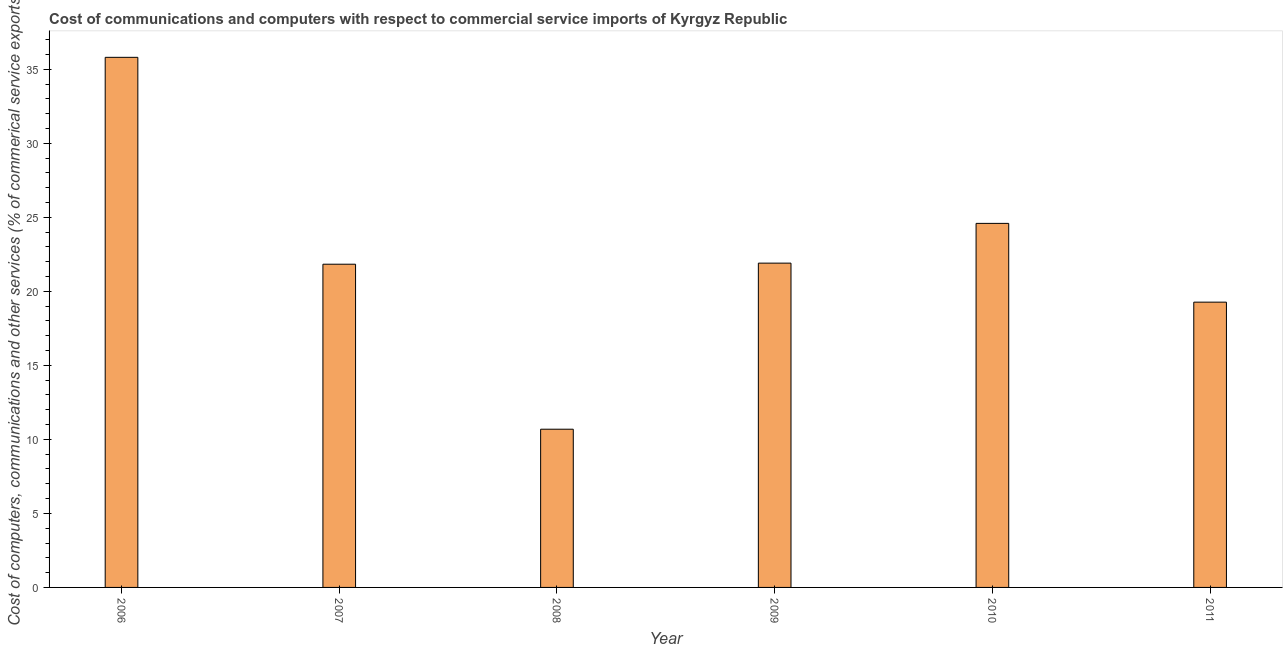Does the graph contain any zero values?
Provide a succinct answer. No. Does the graph contain grids?
Your answer should be compact. No. What is the title of the graph?
Your answer should be very brief. Cost of communications and computers with respect to commercial service imports of Kyrgyz Republic. What is the label or title of the X-axis?
Offer a terse response. Year. What is the label or title of the Y-axis?
Your response must be concise. Cost of computers, communications and other services (% of commerical service exports). What is the  computer and other services in 2008?
Offer a very short reply. 10.69. Across all years, what is the maximum  computer and other services?
Give a very brief answer. 35.81. Across all years, what is the minimum  computer and other services?
Keep it short and to the point. 10.69. What is the sum of the cost of communications?
Offer a terse response. 134.1. What is the difference between the  computer and other services in 2006 and 2010?
Make the answer very short. 11.22. What is the average cost of communications per year?
Provide a succinct answer. 22.35. What is the median cost of communications?
Ensure brevity in your answer.  21.87. What is the ratio of the cost of communications in 2008 to that in 2011?
Offer a terse response. 0.56. Is the difference between the  computer and other services in 2007 and 2011 greater than the difference between any two years?
Ensure brevity in your answer.  No. What is the difference between the highest and the second highest  computer and other services?
Offer a very short reply. 11.22. What is the difference between the highest and the lowest  computer and other services?
Your answer should be very brief. 25.12. In how many years, is the cost of communications greater than the average cost of communications taken over all years?
Provide a succinct answer. 2. How many bars are there?
Your response must be concise. 6. Are all the bars in the graph horizontal?
Make the answer very short. No. How many years are there in the graph?
Offer a terse response. 6. Are the values on the major ticks of Y-axis written in scientific E-notation?
Give a very brief answer. No. What is the Cost of computers, communications and other services (% of commerical service exports) in 2006?
Your response must be concise. 35.81. What is the Cost of computers, communications and other services (% of commerical service exports) in 2007?
Offer a terse response. 21.83. What is the Cost of computers, communications and other services (% of commerical service exports) of 2008?
Give a very brief answer. 10.69. What is the Cost of computers, communications and other services (% of commerical service exports) of 2009?
Provide a short and direct response. 21.91. What is the Cost of computers, communications and other services (% of commerical service exports) in 2010?
Offer a very short reply. 24.59. What is the Cost of computers, communications and other services (% of commerical service exports) of 2011?
Give a very brief answer. 19.27. What is the difference between the Cost of computers, communications and other services (% of commerical service exports) in 2006 and 2007?
Offer a very short reply. 13.98. What is the difference between the Cost of computers, communications and other services (% of commerical service exports) in 2006 and 2008?
Your answer should be very brief. 25.12. What is the difference between the Cost of computers, communications and other services (% of commerical service exports) in 2006 and 2009?
Your answer should be compact. 13.9. What is the difference between the Cost of computers, communications and other services (% of commerical service exports) in 2006 and 2010?
Provide a short and direct response. 11.22. What is the difference between the Cost of computers, communications and other services (% of commerical service exports) in 2006 and 2011?
Offer a very short reply. 16.54. What is the difference between the Cost of computers, communications and other services (% of commerical service exports) in 2007 and 2008?
Keep it short and to the point. 11.15. What is the difference between the Cost of computers, communications and other services (% of commerical service exports) in 2007 and 2009?
Provide a short and direct response. -0.07. What is the difference between the Cost of computers, communications and other services (% of commerical service exports) in 2007 and 2010?
Make the answer very short. -2.76. What is the difference between the Cost of computers, communications and other services (% of commerical service exports) in 2007 and 2011?
Provide a succinct answer. 2.56. What is the difference between the Cost of computers, communications and other services (% of commerical service exports) in 2008 and 2009?
Give a very brief answer. -11.22. What is the difference between the Cost of computers, communications and other services (% of commerical service exports) in 2008 and 2010?
Provide a short and direct response. -13.9. What is the difference between the Cost of computers, communications and other services (% of commerical service exports) in 2008 and 2011?
Your answer should be very brief. -8.58. What is the difference between the Cost of computers, communications and other services (% of commerical service exports) in 2009 and 2010?
Your answer should be very brief. -2.69. What is the difference between the Cost of computers, communications and other services (% of commerical service exports) in 2009 and 2011?
Offer a very short reply. 2.64. What is the difference between the Cost of computers, communications and other services (% of commerical service exports) in 2010 and 2011?
Offer a terse response. 5.32. What is the ratio of the Cost of computers, communications and other services (% of commerical service exports) in 2006 to that in 2007?
Provide a succinct answer. 1.64. What is the ratio of the Cost of computers, communications and other services (% of commerical service exports) in 2006 to that in 2008?
Your response must be concise. 3.35. What is the ratio of the Cost of computers, communications and other services (% of commerical service exports) in 2006 to that in 2009?
Your answer should be compact. 1.64. What is the ratio of the Cost of computers, communications and other services (% of commerical service exports) in 2006 to that in 2010?
Keep it short and to the point. 1.46. What is the ratio of the Cost of computers, communications and other services (% of commerical service exports) in 2006 to that in 2011?
Give a very brief answer. 1.86. What is the ratio of the Cost of computers, communications and other services (% of commerical service exports) in 2007 to that in 2008?
Your response must be concise. 2.04. What is the ratio of the Cost of computers, communications and other services (% of commerical service exports) in 2007 to that in 2009?
Ensure brevity in your answer.  1. What is the ratio of the Cost of computers, communications and other services (% of commerical service exports) in 2007 to that in 2010?
Give a very brief answer. 0.89. What is the ratio of the Cost of computers, communications and other services (% of commerical service exports) in 2007 to that in 2011?
Offer a terse response. 1.13. What is the ratio of the Cost of computers, communications and other services (% of commerical service exports) in 2008 to that in 2009?
Offer a very short reply. 0.49. What is the ratio of the Cost of computers, communications and other services (% of commerical service exports) in 2008 to that in 2010?
Keep it short and to the point. 0.43. What is the ratio of the Cost of computers, communications and other services (% of commerical service exports) in 2008 to that in 2011?
Give a very brief answer. 0.56. What is the ratio of the Cost of computers, communications and other services (% of commerical service exports) in 2009 to that in 2010?
Offer a terse response. 0.89. What is the ratio of the Cost of computers, communications and other services (% of commerical service exports) in 2009 to that in 2011?
Keep it short and to the point. 1.14. What is the ratio of the Cost of computers, communications and other services (% of commerical service exports) in 2010 to that in 2011?
Provide a succinct answer. 1.28. 